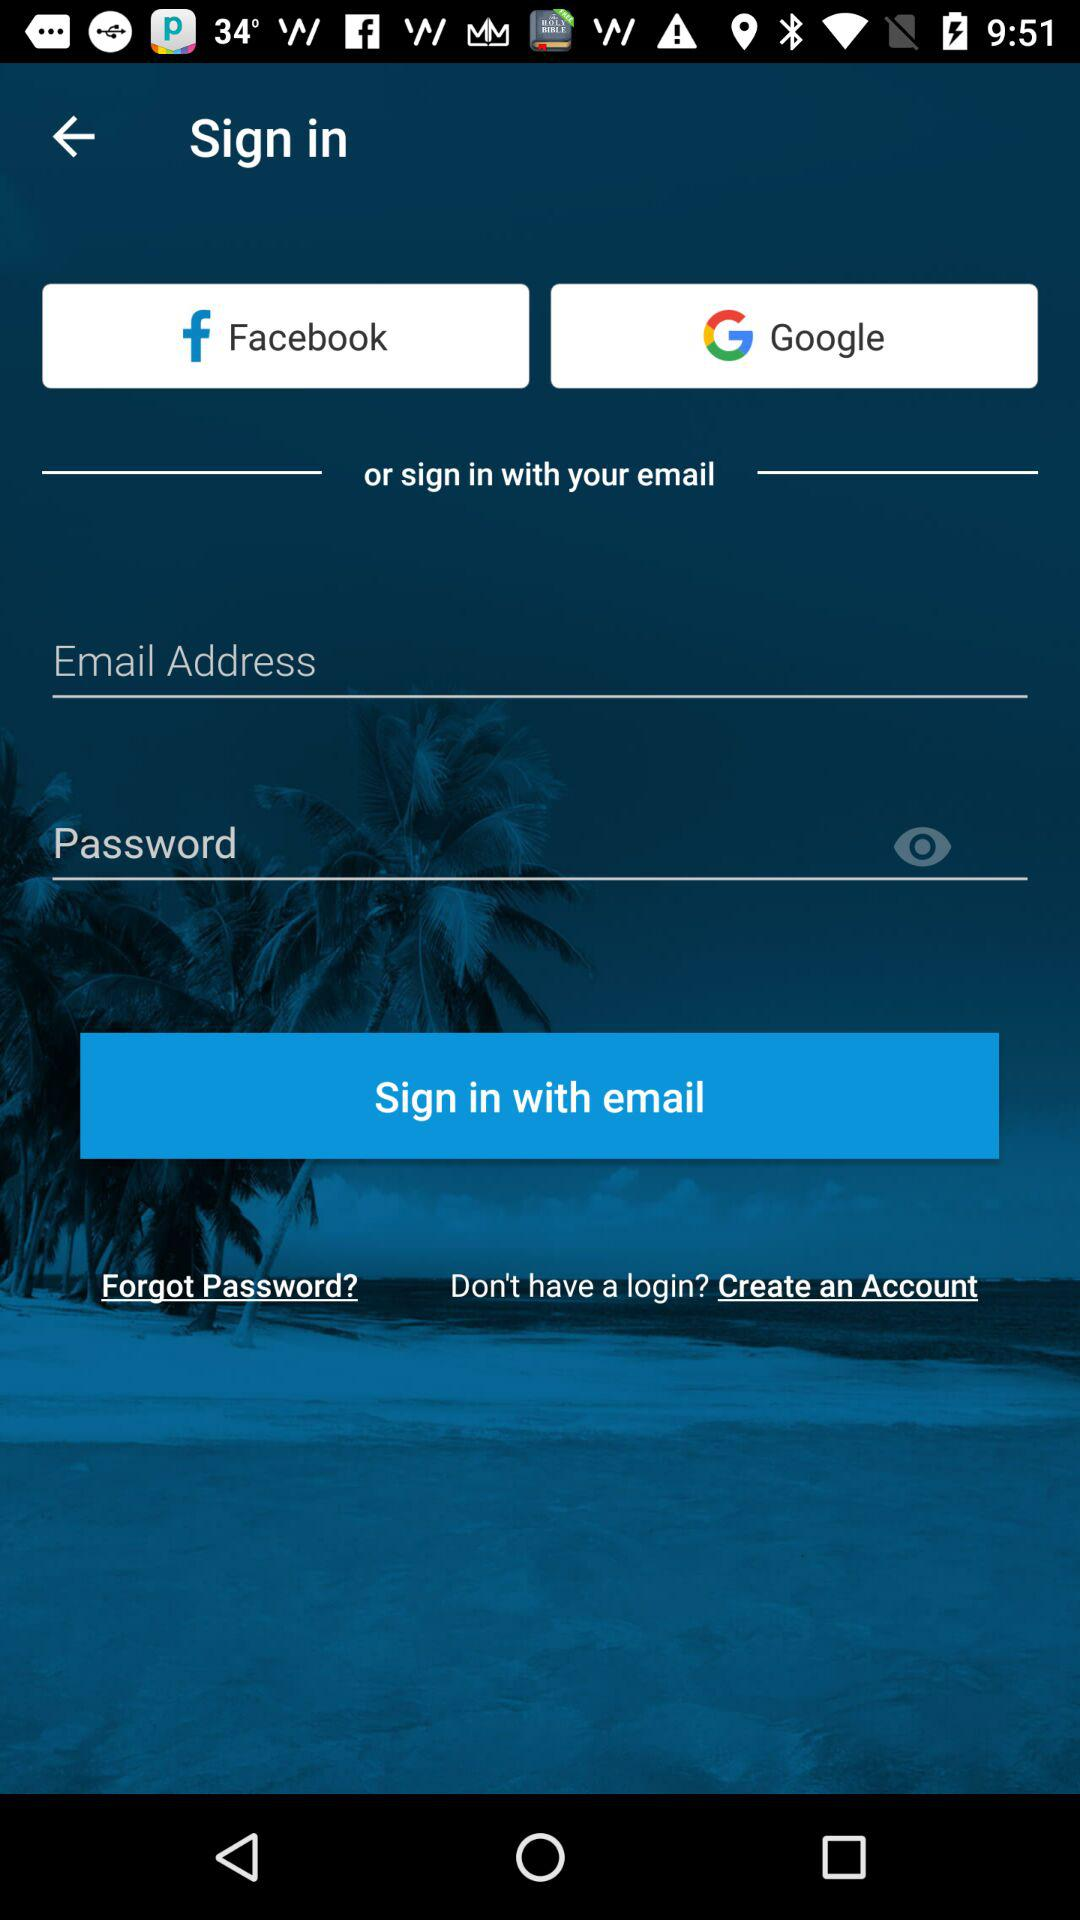What is the entered email address?
When the provided information is insufficient, respond with <no answer>. <no answer> 